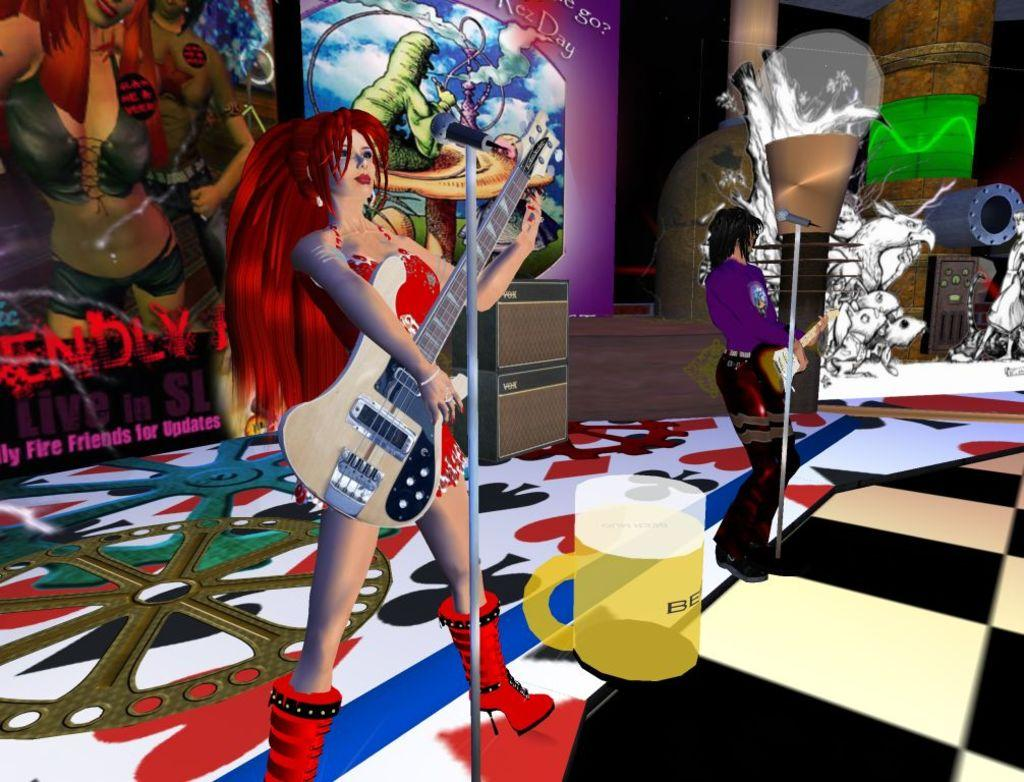What style is the image drawn in? The image is a cartoon. Who is the main subject in the image? There is a woman in the image. What is the woman doing in the image? The woman is playing a guitar. How many snakes are wrapped around the woman's guitar? There are no snakes present in the image; it features a woman playing a guitar in a cartoon style. 